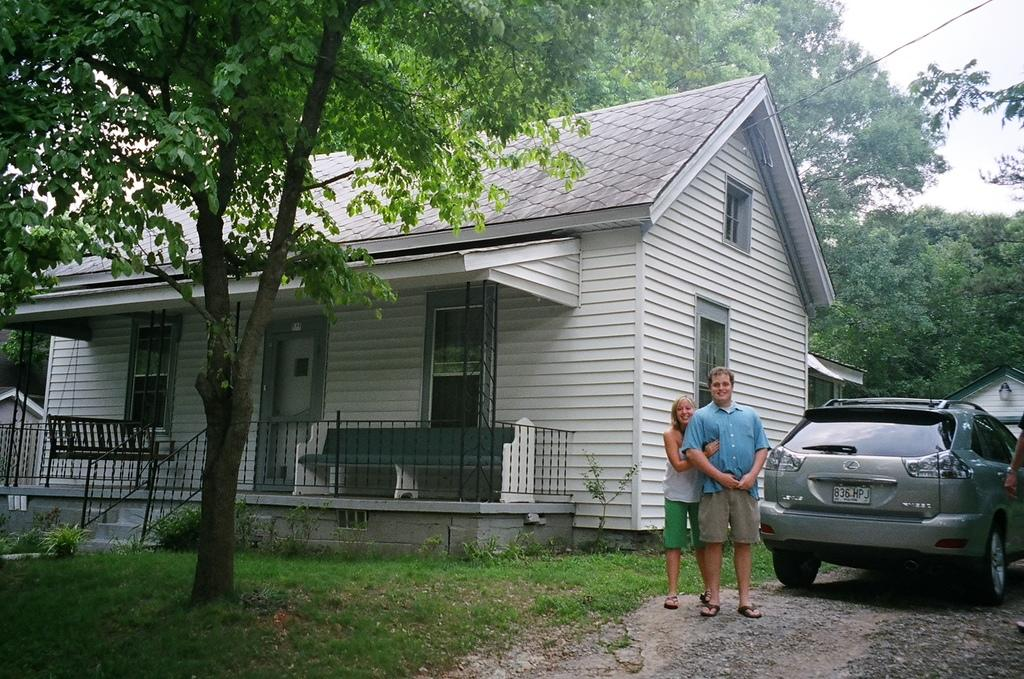What are the two people in the image doing? There is a couple standing on a road in the image. What can be seen behind the couple? There is a house behind the couple. What is located behind the house? There is a car behind the house, and there are trees behind the house as well. What type of vegetation is present on the bottom left of the image? There is grassland and a tree on the bottom left of the image. What type of vegetable is being used to build the house in the image? There is no vegetable being used to build the house in the image; it is a regular house made of conventional building materials. 